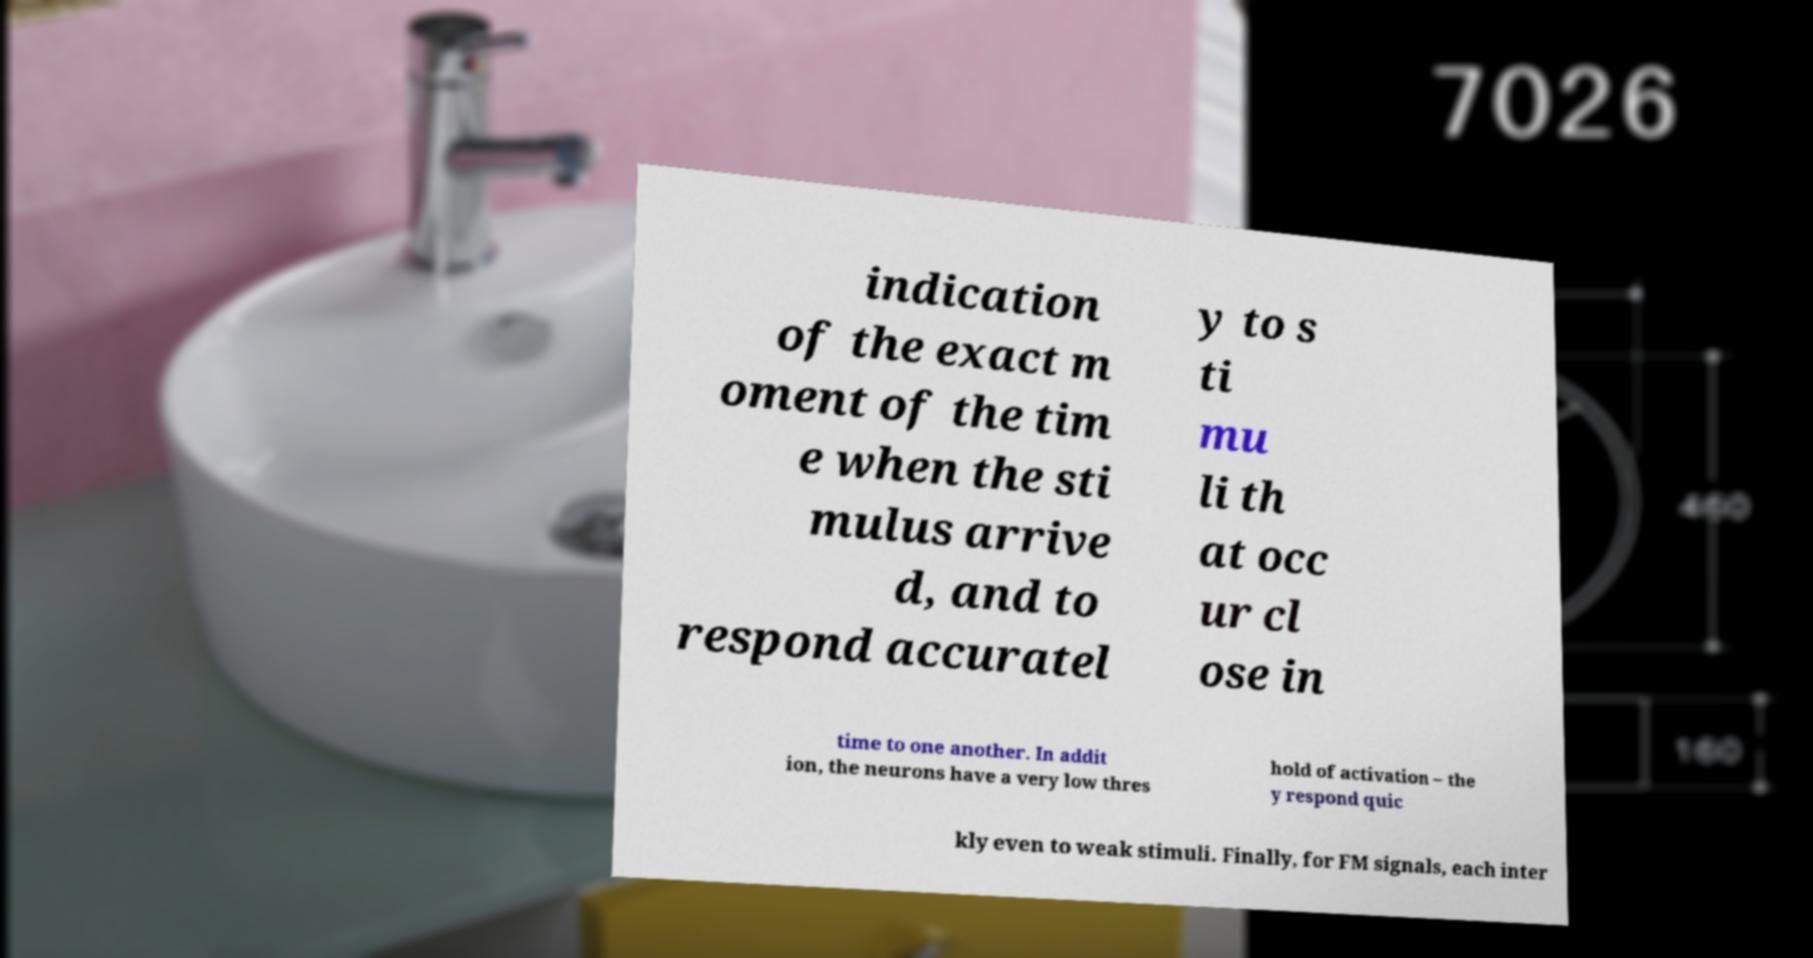There's text embedded in this image that I need extracted. Can you transcribe it verbatim? indication of the exact m oment of the tim e when the sti mulus arrive d, and to respond accuratel y to s ti mu li th at occ ur cl ose in time to one another. In addit ion, the neurons have a very low thres hold of activation – the y respond quic kly even to weak stimuli. Finally, for FM signals, each inter 